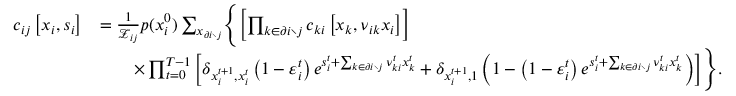Convert formula to latex. <formula><loc_0><loc_0><loc_500><loc_500>\begin{array} { r l } { c _ { i j } \left [ x _ { i } , s _ { i } \right ] } & { = \frac { 1 } { \mathcal { Z } _ { i j } } p ( x _ { i } ^ { 0 } ) \sum _ { x _ { \partial i \ j } } \left \{ \left [ \prod _ { k \in \partial i \ j } c _ { k i } \left [ x _ { k } , \nu _ { i k } x _ { i } \right ] \right ] } \\ & { \quad \times \prod _ { t = 0 } ^ { T - 1 } \left [ \delta _ { x _ { i } ^ { t + 1 } , x _ { i } ^ { t } } \left ( 1 - \varepsilon _ { i } ^ { t } \right ) e ^ { s _ { i } ^ { t } + \sum _ { k \in \partial i \ j } \nu _ { k i } ^ { t } x _ { k } ^ { t } } + \delta _ { x _ { i } ^ { t + 1 } , 1 } \left ( 1 - \left ( 1 - \varepsilon _ { i } ^ { t } \right ) e ^ { s _ { i } ^ { t } + \sum _ { k \in \partial i \ j } \nu _ { k i } ^ { t } x _ { k } ^ { t } } \right ) \right ] \right \} . } \end{array}</formula> 